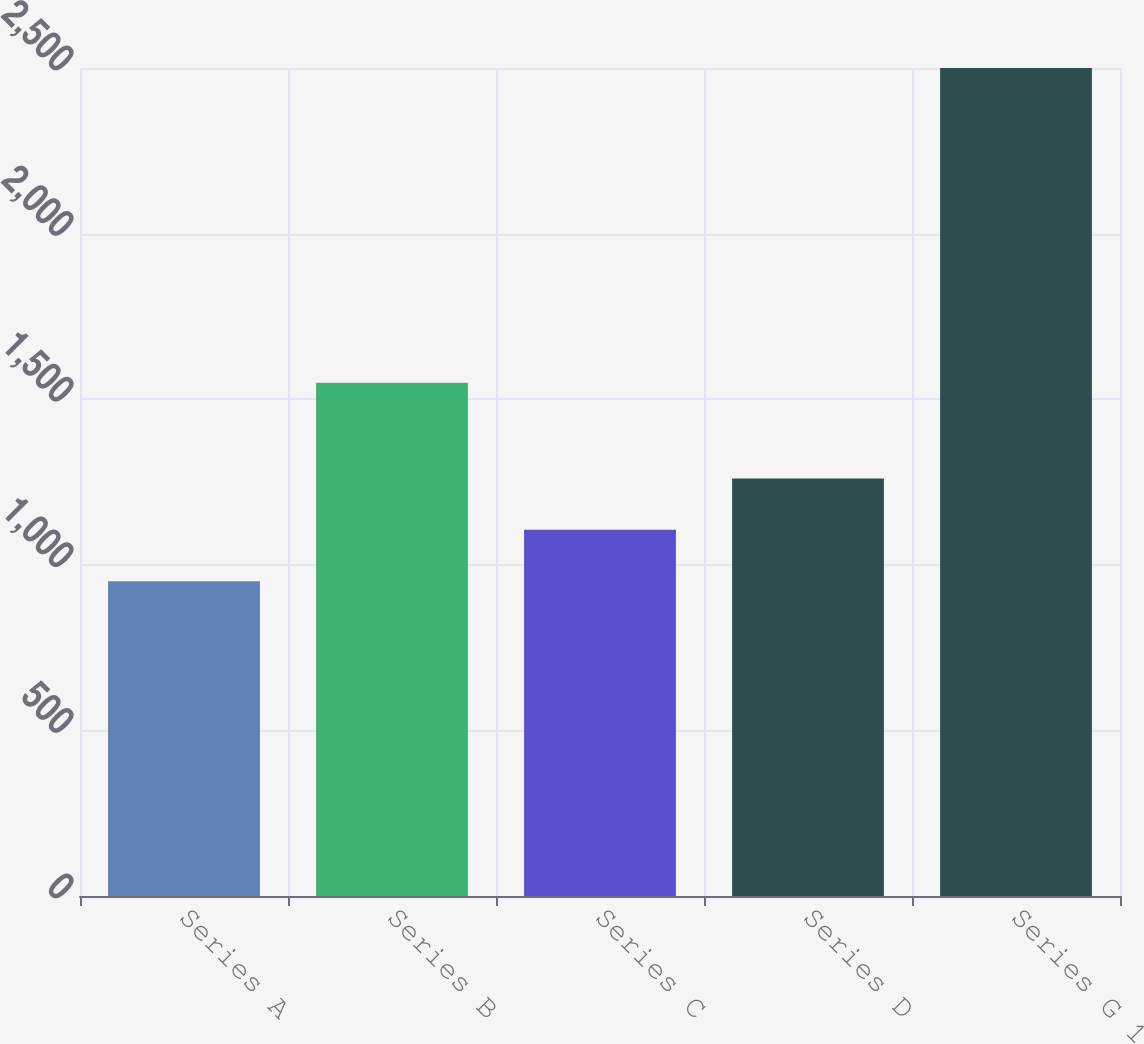<chart> <loc_0><loc_0><loc_500><loc_500><bar_chart><fcel>Series A<fcel>Series B<fcel>Series C<fcel>Series D<fcel>Series G 1<nl><fcel>950.51<fcel>1550<fcel>1105.46<fcel>1260.41<fcel>2500<nl></chart> 